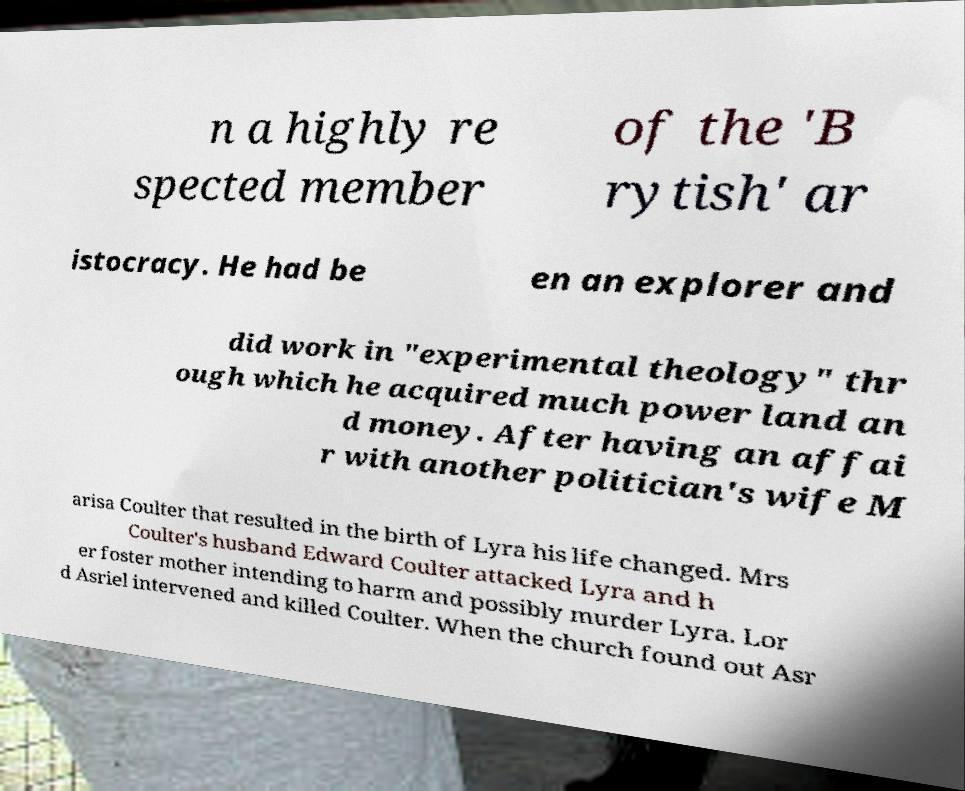For documentation purposes, I need the text within this image transcribed. Could you provide that? n a highly re spected member of the 'B rytish' ar istocracy. He had be en an explorer and did work in "experimental theology" thr ough which he acquired much power land an d money. After having an affai r with another politician's wife M arisa Coulter that resulted in the birth of Lyra his life changed. Mrs Coulter's husband Edward Coulter attacked Lyra and h er foster mother intending to harm and possibly murder Lyra. Lor d Asriel intervened and killed Coulter. When the church found out Asr 